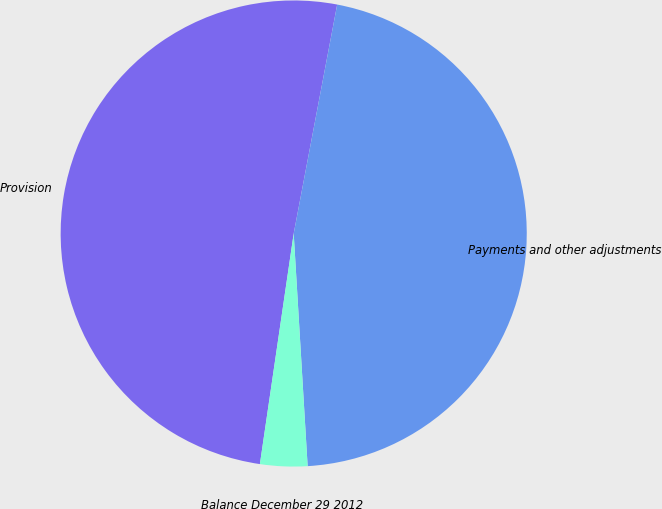Convert chart to OTSL. <chart><loc_0><loc_0><loc_500><loc_500><pie_chart><fcel>Provision<fcel>Payments and other adjustments<fcel>Balance December 29 2012<nl><fcel>50.67%<fcel>46.06%<fcel>3.27%<nl></chart> 